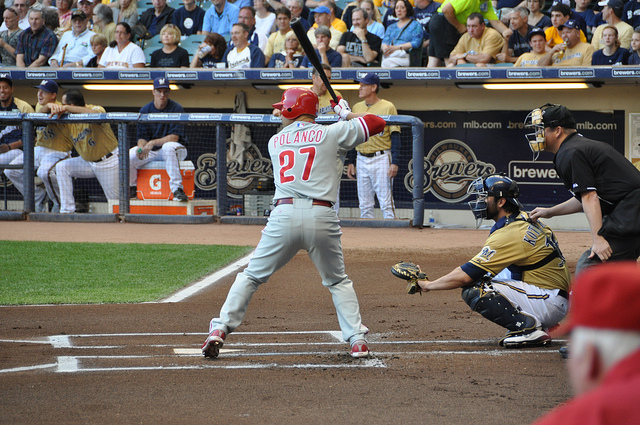Read and extract the text from this image. Bewer POLANCO 27 G ins.com Grewers brewe mlb.com mlb.com 